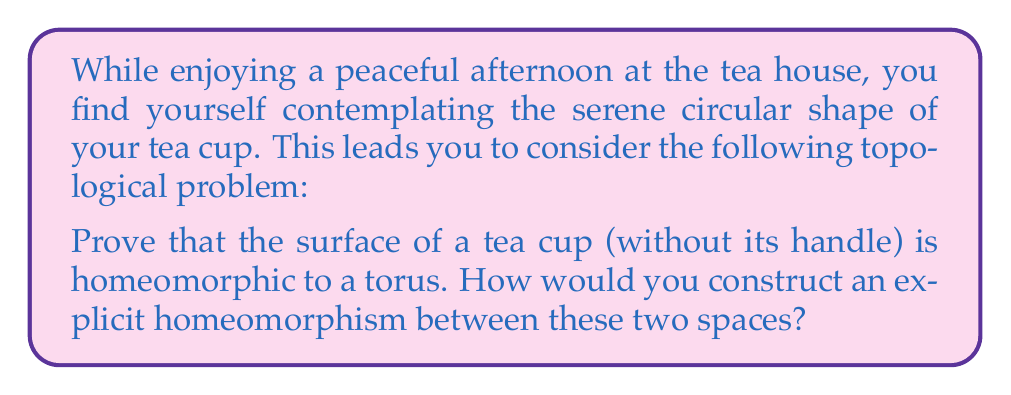Can you answer this question? To prove that the surface of a tea cup (without its handle) is homeomorphic to a torus, we need to construct a continuous bijective function with a continuous inverse between these two spaces. Let's approach this step-by-step:

1. Visualize the spaces:
   - The surface of a tea cup can be thought of as a cylinder with one end closed.
   - A torus is a donut-shaped surface.

2. Construct the homeomorphism:
   a) Start with the tea cup surface. We can parameterize it using cylindrical coordinates $(r, \theta, z)$, where $0 \leq r \leq R$, $0 \leq \theta < 2\pi$, and $0 \leq z \leq H$.

   b) Define a function $f$ that maps the tea cup surface to the torus:

      $$f(r, \theta, z) = ((R + r\cos(\frac{\pi z}{H}))\cos(\theta), (R + r\cos(\frac{\pi z}{H}))\sin(\theta), r\sin(\frac{\pi z}{H}))$$

      Where $R$ is the distance from the center of the torus tube to the center of the torus, and $r$ is the radius of the tube.

3. Prove continuity:
   The function $f$ is composed of continuous functions (sine, cosine, and basic arithmetic operations), so it is continuous.

4. Prove bijectivity:
   - Injective: Different points on the tea cup surface map to different points on the torus.
   - Surjective: Every point on the torus is reached by some point from the tea cup surface.

5. Construct the inverse function:
   The inverse function $f^{-1}$ can be defined as:

   $$f^{-1}(x, y, z) = (\sqrt{z^2 + (\sqrt{x^2 + y^2} - R)^2}, \arctan2(y, x), \frac{H}{\pi}\arctan2(z, \sqrt{x^2 + y^2} - R))$$

6. Prove continuity of the inverse:
   The inverse function is also composed of continuous functions, so it is continuous.

This construction provides an explicit homeomorphism between the surface of a tea cup and a torus, proving that they are topologically equivalent.
Answer: The surface of a tea cup (without its handle) is indeed homeomorphic to a torus. An explicit homeomorphism $f$ from the tea cup surface to the torus is given by:

$$f(r, \theta, z) = ((R + r\cos(\frac{\pi z}{H}))\cos(\theta), (R + r\cos(\frac{\pi z}{H}))\sin(\theta), r\sin(\frac{\pi z}{H}))$$

Where $(r, \theta, z)$ are cylindrical coordinates on the tea cup surface, $R$ is the distance from the center of the torus tube to the center of the torus, and $H$ is the height of the tea cup. 